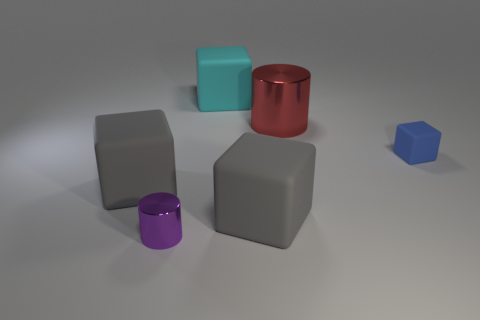Is there a small object that has the same color as the tiny cylinder?
Your response must be concise. No. The cyan cube that is the same material as the small blue cube is what size?
Ensure brevity in your answer.  Large. Is the color of the large metal object the same as the small metal cylinder?
Ensure brevity in your answer.  No. There is a tiny shiny object that is to the left of the red cylinder; does it have the same shape as the big red metal object?
Provide a succinct answer. Yes. What number of other objects are the same size as the cyan rubber object?
Provide a short and direct response. 3. Are there any large cyan blocks to the left of the small thing on the left side of the large red cylinder?
Provide a short and direct response. No. How many objects are cylinders that are left of the cyan rubber block or red cylinders?
Offer a terse response. 2. How many shiny things are there?
Your answer should be compact. 2. What is the shape of the cyan object that is made of the same material as the blue thing?
Your answer should be compact. Cube. How big is the gray rubber cube right of the large rubber thing behind the blue object?
Provide a short and direct response. Large. 